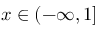Convert formula to latex. <formula><loc_0><loc_0><loc_500><loc_500>x \in ( - \infty , 1 ]</formula> 